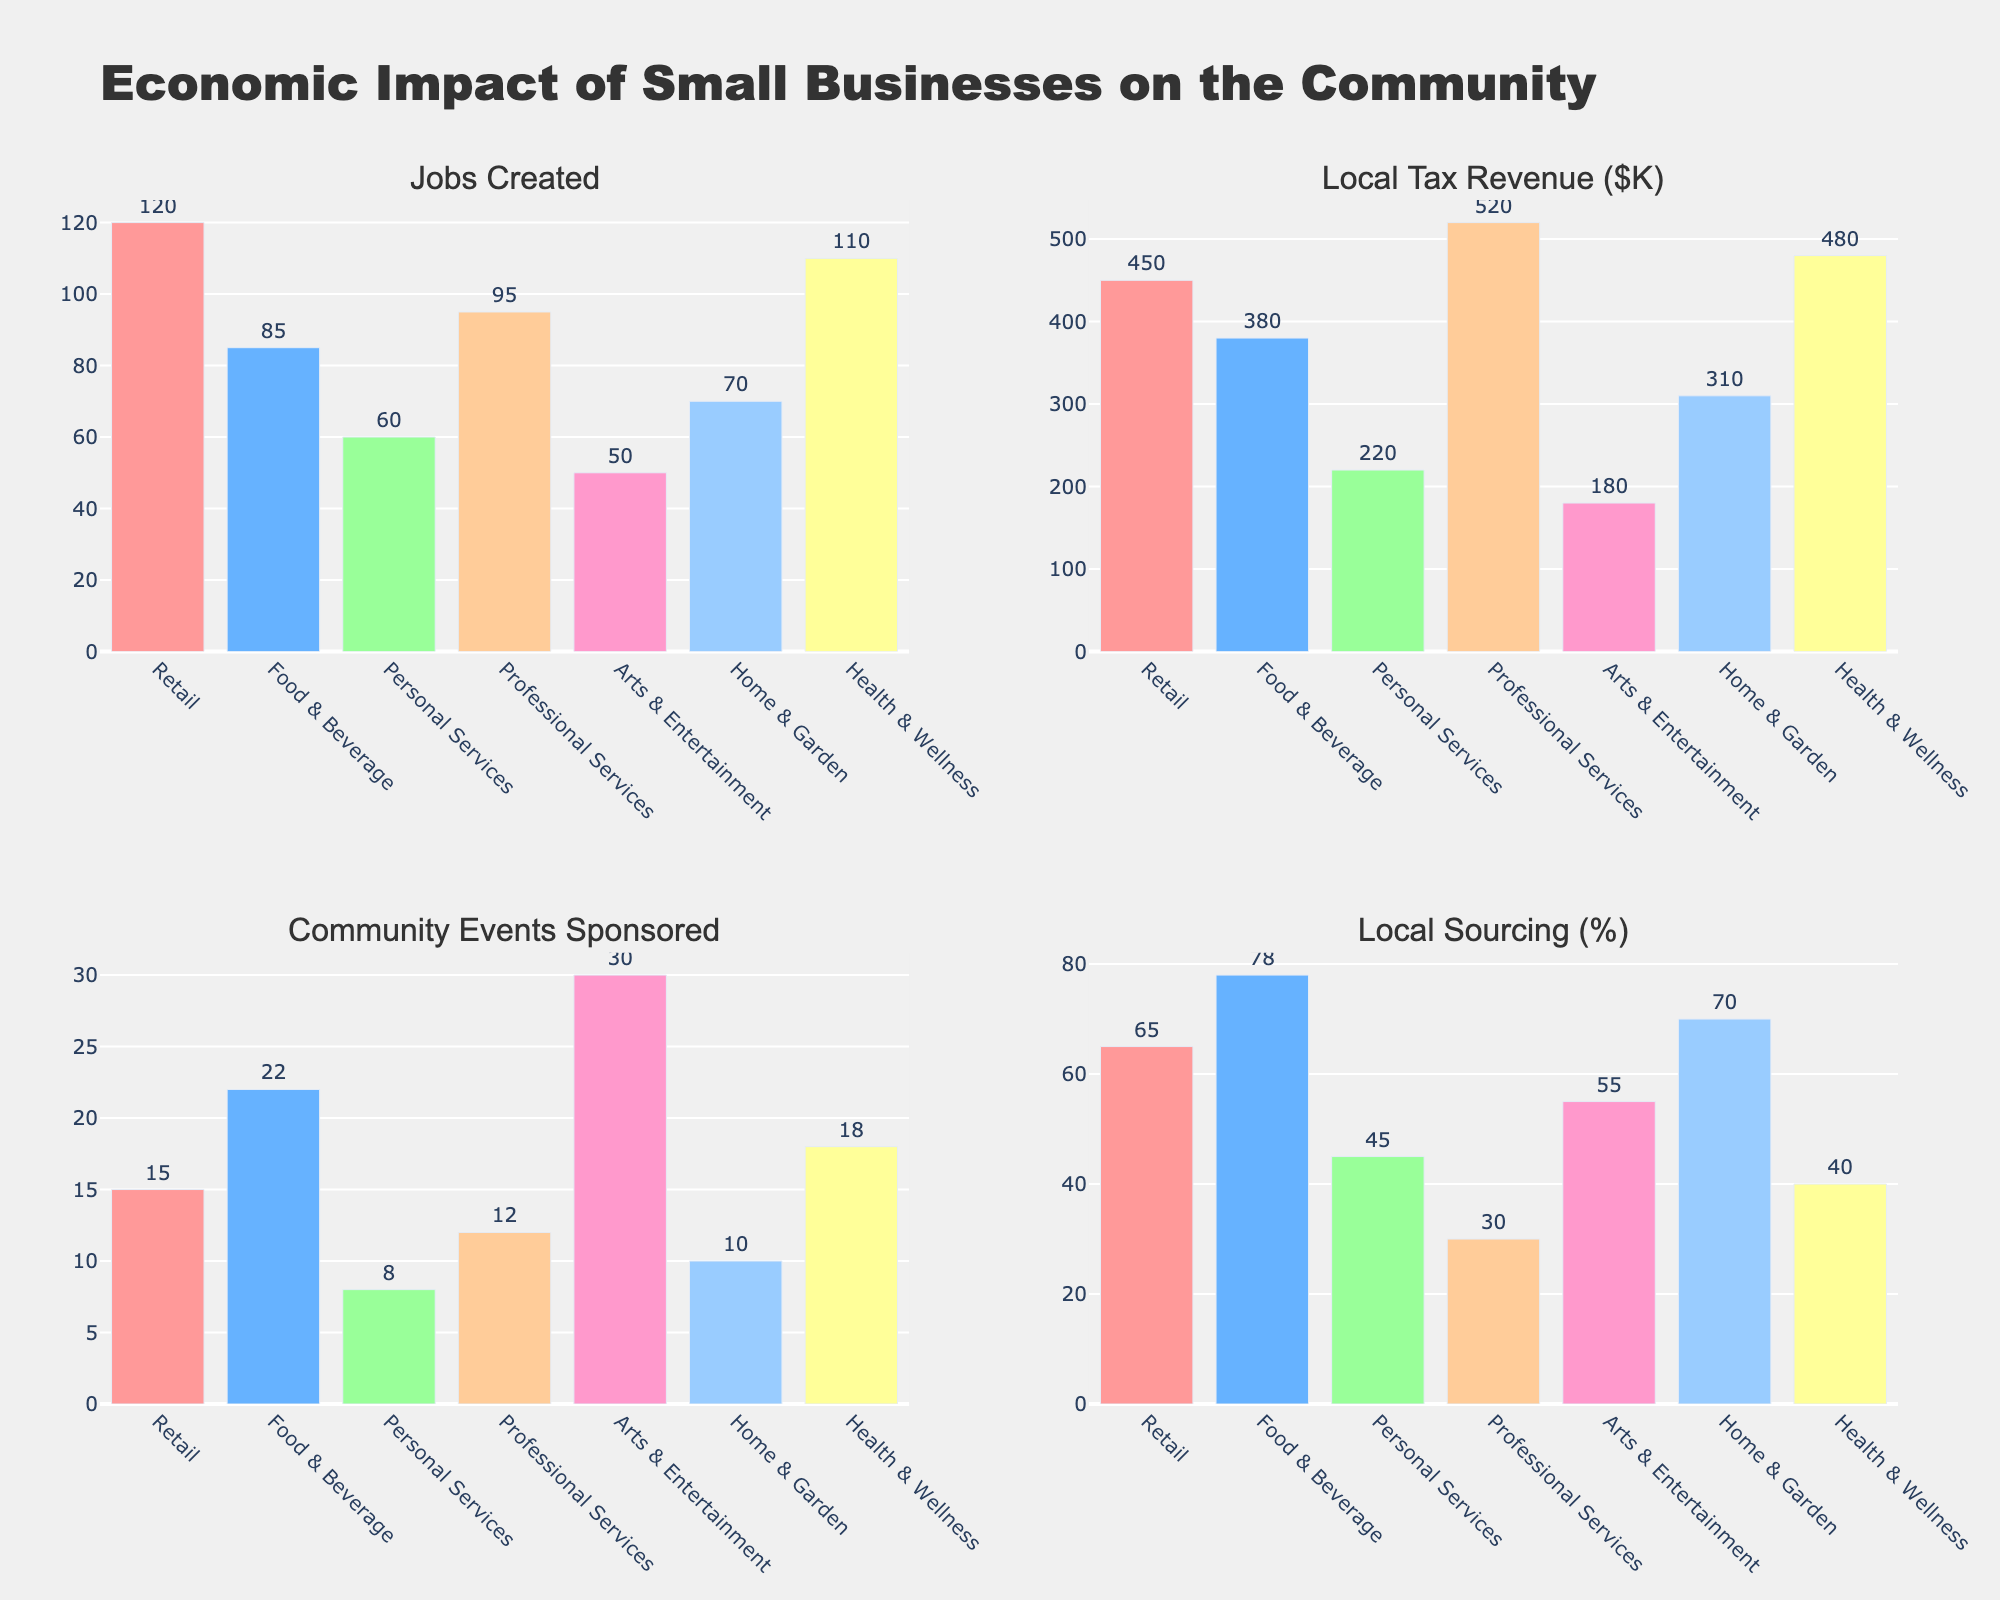How many industries are represented in the subplots? To find the number of industries, count the unique industries listed on the x-axis of any of the subplots. They are: Retail, Food & Beverage, Personal Services, Professional Services, Arts & Entertainment, Home & Garden, and Health & Wellness.
Answer: 7 Which industry created the most jobs? To find the industry that created the most jobs, look at the "Jobs Created" subplot and identify the highest bar. The Retail industry has the highest bar.
Answer: Retail What is the total local tax revenue generated by all industries combined? To find the total local tax revenue, sum the values shown on the "Local Tax Revenue ($K)" subplot: 450 + 380 + 220 + 520 + 180 + 310 + 480 = 2540
Answer: 2540 Which industry sponsored the most community events? To find the industry that sponsored the most community events, look at the "Community Events Sponsored" subplot and identify the highest bar. The Arts & Entertainment industry has the highest bar.
Answer: Arts & Entertainment What is the average percentage of local sourcing across all industries? To find the average percentage of local sourcing, sum the values shown on the "Local Sourcing (%)" subplot: 65 + 78 + 45 + 30 + 55 + 70 + 40 = 383. Then divide by the number of industries (7). 383 / 7 ≈ 54.71
Answer: 54.71 Which industry generated the least local tax revenue? To find the industry that generated the least local tax revenue, look at the "Local Tax Revenue ($K)" subplot and identify the lowest bar. The Arts & Entertainment industry has the lowest bar.
Answer: Arts & Entertainment Compare the number of jobs created by the Health & Wellness industry and the Professional Services industry. Which one created more? To compare the number of jobs created, look at the "Jobs Created" subplot. Health & Wellness created 110 jobs and Professional Services created 95 jobs. Health & Wellness created more jobs.
Answer: Health & Wellness Which industry has the highest percentage of local sourcing? To find which industry has the highest percentage of local sourcing, look at the "Local Sourcing (%)" subplot and identify the highest bar. The Food & Beverage industry has the highest bar.
Answer: Food & Beverage How many community events did the Retail and Personal Services industries sponsor combined? To find the combined number of community events sponsored, add the values from the "Community Events Sponsored" subplot for Retail (15) and Personal Services (8). 15 + 8 = 23
Answer: 23 Is there any industry that ranks highest in more than one category? To check if any industry ranks highest in more than one category, identify the top-ranked industry in each subplot: 
- Jobs Created: Retail
- Local Tax Revenue: Professional Services
- Community Events Sponsored: Arts & Entertainment
- Local Sourcing: Food & Beverage
None of the industries rank highest in more than one category.
Answer: No 